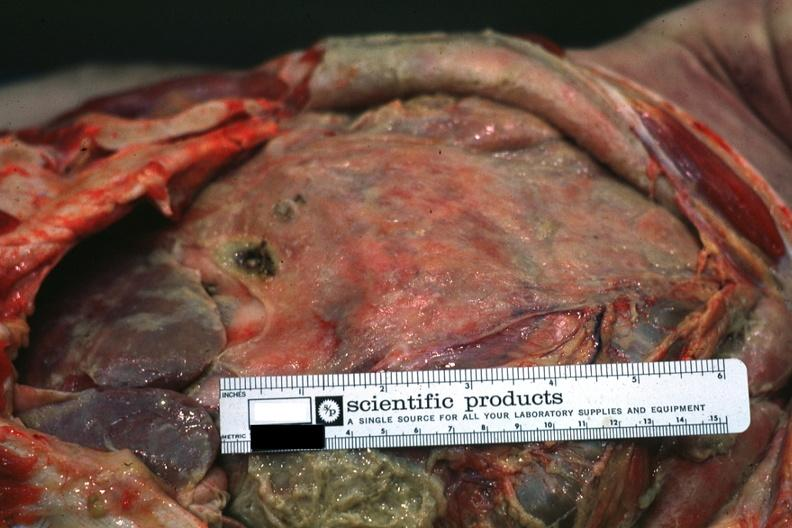s tuberculous peritonitis present?
Answer the question using a single word or phrase. No 